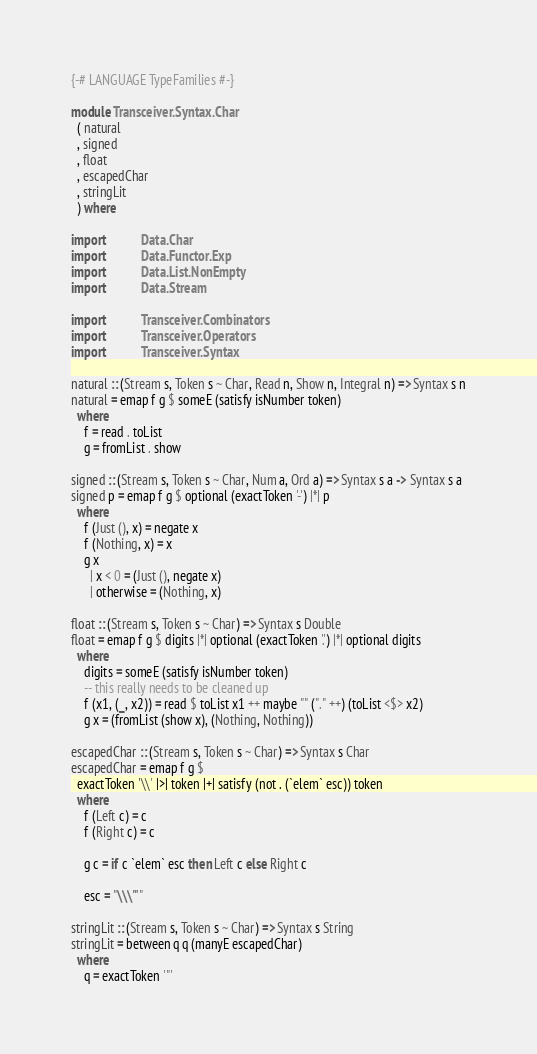<code> <loc_0><loc_0><loc_500><loc_500><_Haskell_>{-# LANGUAGE TypeFamilies #-}

module Transceiver.Syntax.Char
  ( natural
  , signed
  , float
  , escapedChar
  , stringLit
  ) where

import           Data.Char
import           Data.Functor.Exp
import           Data.List.NonEmpty
import           Data.Stream

import           Transceiver.Combinators
import           Transceiver.Operators
import           Transceiver.Syntax

natural :: (Stream s, Token s ~ Char, Read n, Show n, Integral n) => Syntax s n
natural = emap f g $ someE (satisfy isNumber token)
  where
    f = read . toList
    g = fromList . show

signed :: (Stream s, Token s ~ Char, Num a, Ord a) => Syntax s a -> Syntax s a
signed p = emap f g $ optional (exactToken '-') |*| p
  where
    f (Just (), x) = negate x
    f (Nothing, x) = x
    g x
      | x < 0 = (Just (), negate x)
      | otherwise = (Nothing, x)

float :: (Stream s, Token s ~ Char) => Syntax s Double
float = emap f g $ digits |*| optional (exactToken '.') |*| optional digits
  where
    digits = someE (satisfy isNumber token)
    -- this really needs to be cleaned up
    f (x1, (_, x2)) = read $ toList x1 ++ maybe "" ("." ++) (toList <$> x2)
    g x = (fromList (show x), (Nothing, Nothing))

escapedChar :: (Stream s, Token s ~ Char) => Syntax s Char
escapedChar = emap f g $
  exactToken '\\' |>| token |+| satisfy (not . (`elem` esc)) token
  where
    f (Left c) = c
    f (Right c) = c

    g c = if c `elem` esc then Left c else Right c

    esc = "\\\"'"

stringLit :: (Stream s, Token s ~ Char) => Syntax s String
stringLit = between q q (manyE escapedChar)
  where
    q = exactToken '"'
</code> 